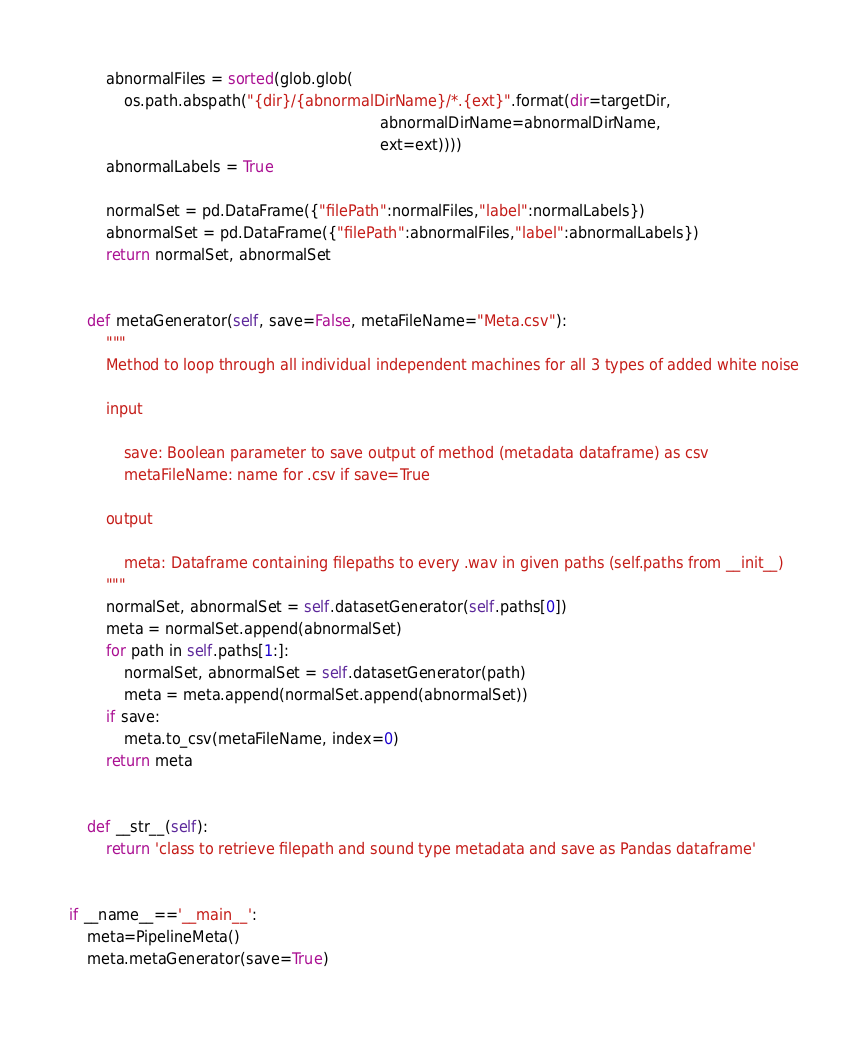<code> <loc_0><loc_0><loc_500><loc_500><_Python_>        abnormalFiles = sorted(glob.glob(
            os.path.abspath("{dir}/{abnormalDirName}/*.{ext}".format(dir=targetDir,
                                                                    abnormalDirName=abnormalDirName,
                                                                    ext=ext))))
        abnormalLabels = True

        normalSet = pd.DataFrame({"filePath":normalFiles,"label":normalLabels})
        abnormalSet = pd.DataFrame({"filePath":abnormalFiles,"label":abnormalLabels})
        return normalSet, abnormalSet
    
    
    def metaGenerator(self, save=False, metaFileName="Meta.csv"):
        """
        Method to loop through all individual independent machines for all 3 types of added white noise
        
        input
        
            save: Boolean parameter to save output of method (metadata dataframe) as csv
            metaFileName: name for .csv if save=True
            
        output
        
            meta: Dataframe containing filepaths to every .wav in given paths (self.paths from __init__)
        """
        normalSet, abnormalSet = self.datasetGenerator(self.paths[0])
        meta = normalSet.append(abnormalSet) 
        for path in self.paths[1:]:
            normalSet, abnormalSet = self.datasetGenerator(path)
            meta = meta.append(normalSet.append(abnormalSet))
        if save:
            meta.to_csv(metaFileName, index=0)
        return meta
    
        
    def __str__(self):
        return 'class to retrieve filepath and sound type metadata and save as Pandas dataframe'
    
    
if __name__=='__main__':
    meta=PipelineMeta()
    meta.metaGenerator(save=True)</code> 